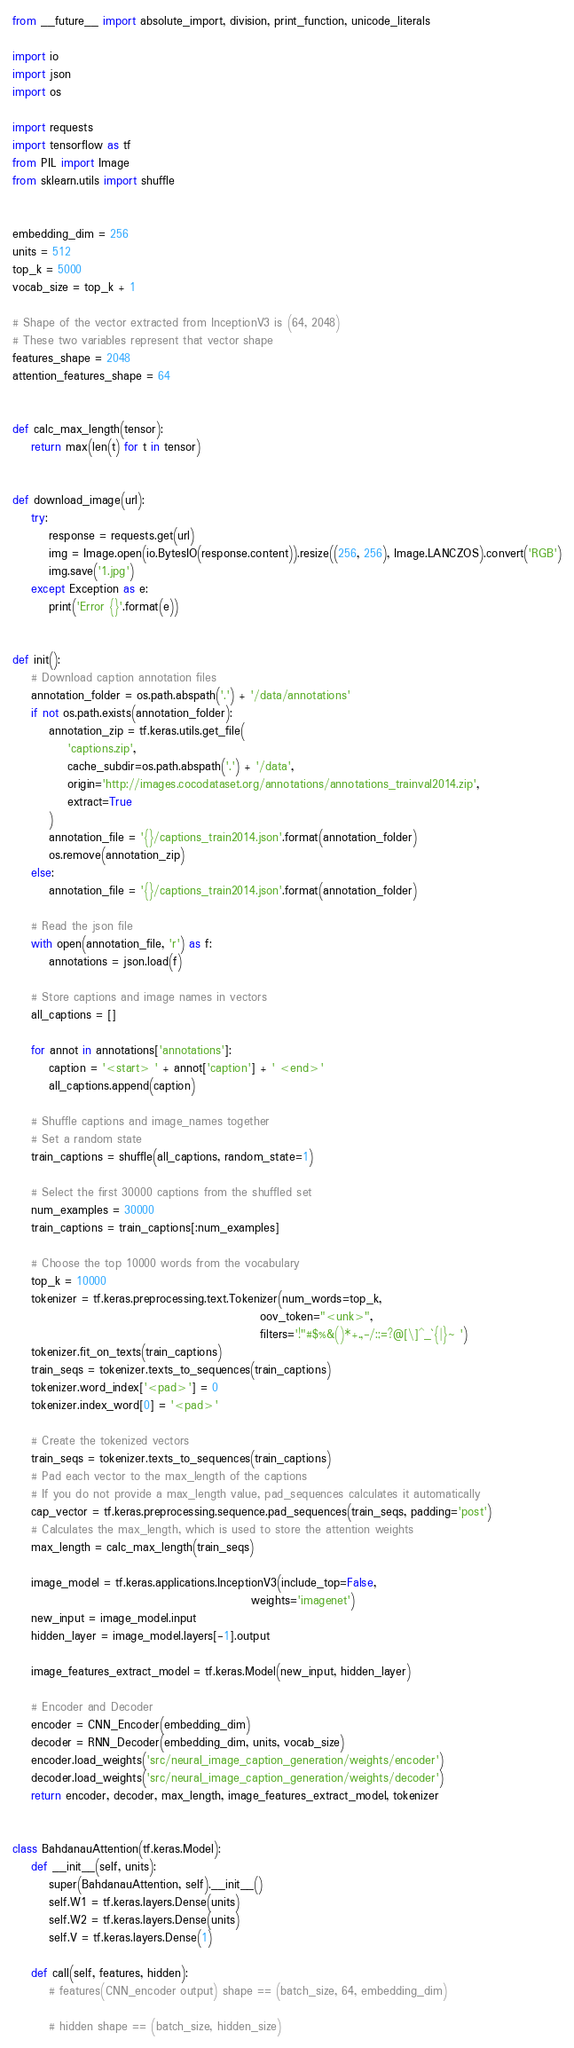<code> <loc_0><loc_0><loc_500><loc_500><_Python_>from __future__ import absolute_import, division, print_function, unicode_literals

import io
import json
import os

import requests
import tensorflow as tf
from PIL import Image
from sklearn.utils import shuffle


embedding_dim = 256
units = 512
top_k = 5000
vocab_size = top_k + 1

# Shape of the vector extracted from InceptionV3 is (64, 2048)
# These two variables represent that vector shape
features_shape = 2048
attention_features_shape = 64


def calc_max_length(tensor):
    return max(len(t) for t in tensor)


def download_image(url):
    try:
        response = requests.get(url)
        img = Image.open(io.BytesIO(response.content)).resize((256, 256), Image.LANCZOS).convert('RGB')
        img.save('1.jpg')
    except Exception as e:
        print('Error {}'.format(e))


def init():
    # Download caption annotation files
    annotation_folder = os.path.abspath('.') + '/data/annotations'
    if not os.path.exists(annotation_folder):
        annotation_zip = tf.keras.utils.get_file(
            'captions.zip',
            cache_subdir=os.path.abspath('.') + '/data',
            origin='http://images.cocodataset.org/annotations/annotations_trainval2014.zip',
            extract=True
        )
        annotation_file = '{}/captions_train2014.json'.format(annotation_folder)
        os.remove(annotation_zip)
    else:
        annotation_file = '{}/captions_train2014.json'.format(annotation_folder)

    # Read the json file
    with open(annotation_file, 'r') as f:
        annotations = json.load(f)

    # Store captions and image names in vectors
    all_captions = []

    for annot in annotations['annotations']:
        caption = '<start> ' + annot['caption'] + ' <end>'
        all_captions.append(caption)

    # Shuffle captions and image_names together
    # Set a random state
    train_captions = shuffle(all_captions, random_state=1)

    # Select the first 30000 captions from the shuffled set
    num_examples = 30000
    train_captions = train_captions[:num_examples]

    # Choose the top 10000 words from the vocabulary
    top_k = 10000
    tokenizer = tf.keras.preprocessing.text.Tokenizer(num_words=top_k,
                                                      oov_token="<unk>",
                                                      filters='!"#$%&()*+.,-/:;=?@[\]^_`{|}~ ')
    tokenizer.fit_on_texts(train_captions)
    train_seqs = tokenizer.texts_to_sequences(train_captions)
    tokenizer.word_index['<pad>'] = 0
    tokenizer.index_word[0] = '<pad>'

    # Create the tokenized vectors
    train_seqs = tokenizer.texts_to_sequences(train_captions)
    # Pad each vector to the max_length of the captions
    # If you do not provide a max_length value, pad_sequences calculates it automatically
    cap_vector = tf.keras.preprocessing.sequence.pad_sequences(train_seqs, padding='post')
    # Calculates the max_length, which is used to store the attention weights
    max_length = calc_max_length(train_seqs)

    image_model = tf.keras.applications.InceptionV3(include_top=False,
                                                    weights='imagenet')
    new_input = image_model.input
    hidden_layer = image_model.layers[-1].output

    image_features_extract_model = tf.keras.Model(new_input, hidden_layer)

    # Encoder and Decoder
    encoder = CNN_Encoder(embedding_dim)
    decoder = RNN_Decoder(embedding_dim, units, vocab_size)
    encoder.load_weights('src/neural_image_caption_generation/weights/encoder')
    decoder.load_weights('src/neural_image_caption_generation/weights/decoder')
    return encoder, decoder, max_length, image_features_extract_model, tokenizer


class BahdanauAttention(tf.keras.Model):
    def __init__(self, units):
        super(BahdanauAttention, self).__init__()
        self.W1 = tf.keras.layers.Dense(units)
        self.W2 = tf.keras.layers.Dense(units)
        self.V = tf.keras.layers.Dense(1)

    def call(self, features, hidden):
        # features(CNN_encoder output) shape == (batch_size, 64, embedding_dim)

        # hidden shape == (batch_size, hidden_size)</code> 